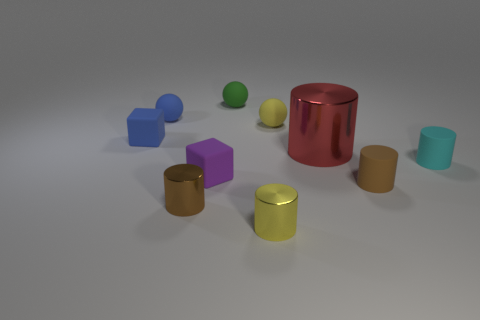There is a rubber cube that is to the left of the small block in front of the cyan cylinder; are there any brown metal objects to the left of it?
Your answer should be compact. No. Is the size of the yellow thing that is to the right of the small yellow metallic cylinder the same as the brown thing that is on the left side of the tiny green thing?
Give a very brief answer. Yes. Are there the same number of matte things in front of the blue sphere and tiny blue matte spheres on the left side of the tiny blue block?
Your answer should be very brief. No. Is there any other thing that has the same material as the small blue block?
Offer a very short reply. Yes. There is a yellow sphere; is its size the same as the object behind the small blue matte sphere?
Make the answer very short. Yes. What material is the brown thing that is on the left side of the rubber cylinder to the left of the cyan thing?
Ensure brevity in your answer.  Metal. Are there the same number of cylinders that are on the right side of the tiny purple rubber object and tiny shiny cylinders?
Provide a succinct answer. No. What size is the object that is in front of the cyan cylinder and to the left of the purple matte block?
Ensure brevity in your answer.  Small. What color is the rubber cylinder that is behind the small brown object to the right of the large object?
Ensure brevity in your answer.  Cyan. How many purple things are either big matte cubes or small rubber things?
Provide a succinct answer. 1. 